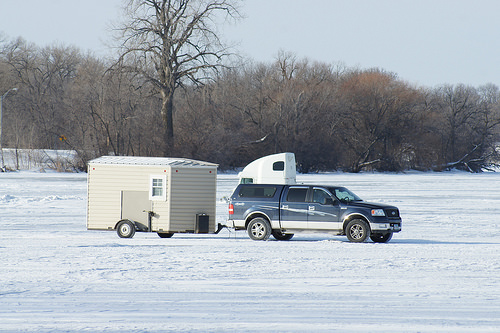<image>
Is the outhouse above the truck? No. The outhouse is not positioned above the truck. The vertical arrangement shows a different relationship. 